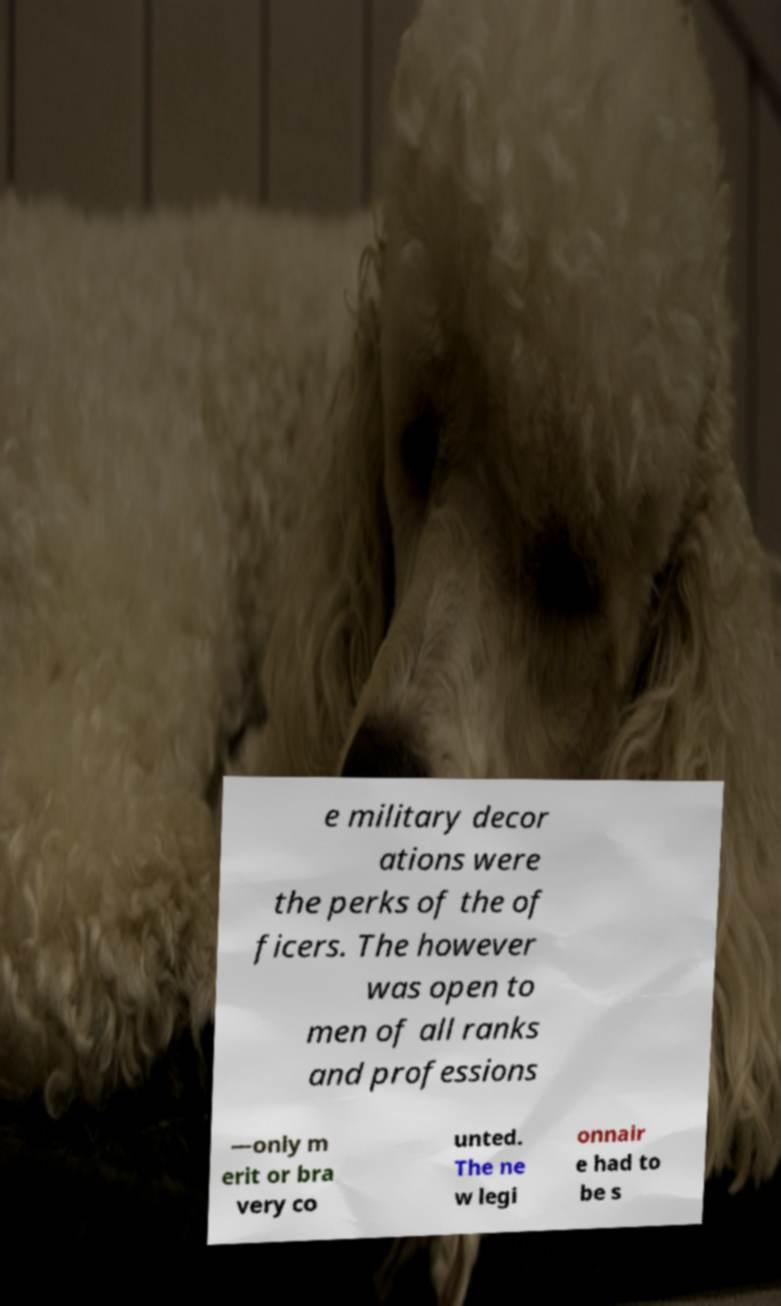Could you assist in decoding the text presented in this image and type it out clearly? e military decor ations were the perks of the of ficers. The however was open to men of all ranks and professions —only m erit or bra very co unted. The ne w legi onnair e had to be s 